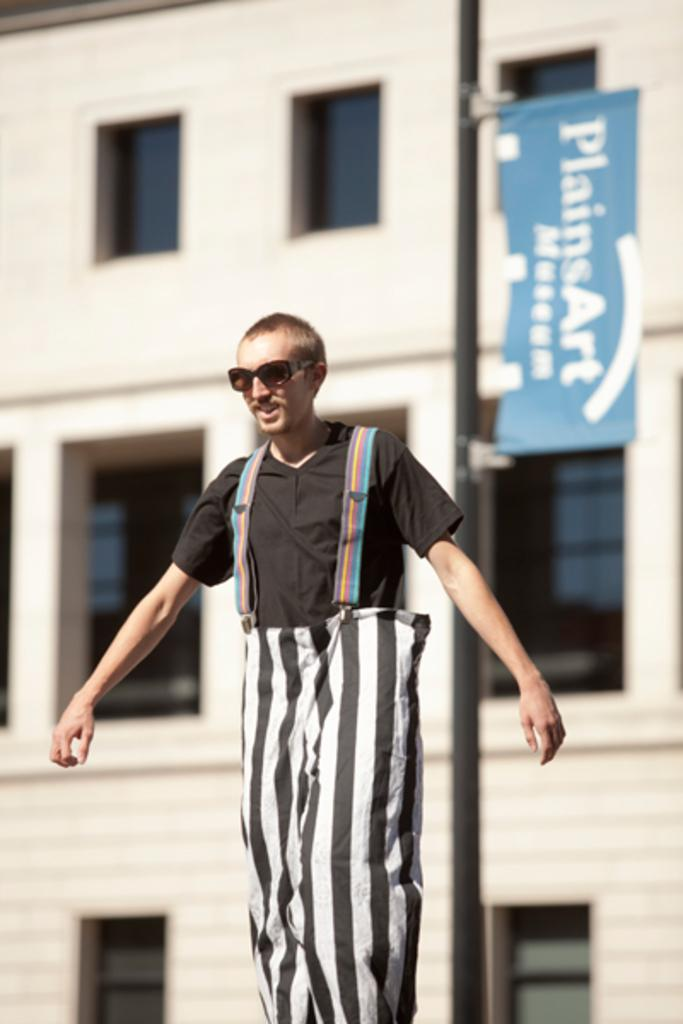What is the main subject of the image? There is a person in the image. What is located behind the person? There is a pole with a banner behind the person. What can be seen in the background of the image? There is a building in the background of the image. How many apples are on the person's head in the image? There are no apples present in the image. What system is the person using to act in the image? The image does not depict any specific system or method of acting; it simply shows a person standing with a pole and banner behind them. 